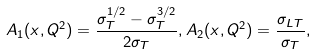<formula> <loc_0><loc_0><loc_500><loc_500>A _ { 1 } ( x , Q ^ { 2 } ) = \frac { \sigma ^ { 1 / 2 } _ { T } - \sigma ^ { 3 / 2 } _ { T } } { 2 \sigma _ { T } } , A _ { 2 } ( x , Q ^ { 2 } ) = \frac { \sigma _ { L T } } { \sigma _ { T } } ,</formula> 